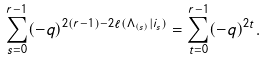<formula> <loc_0><loc_0><loc_500><loc_500>\sum _ { s = 0 } ^ { r - 1 } ( - q ) ^ { 2 ( r - 1 ) - 2 \ell ( \Lambda _ { ( s ) } | i _ { s } ) } = \sum _ { t = 0 } ^ { r - 1 } ( - q ) ^ { 2 t } .</formula> 